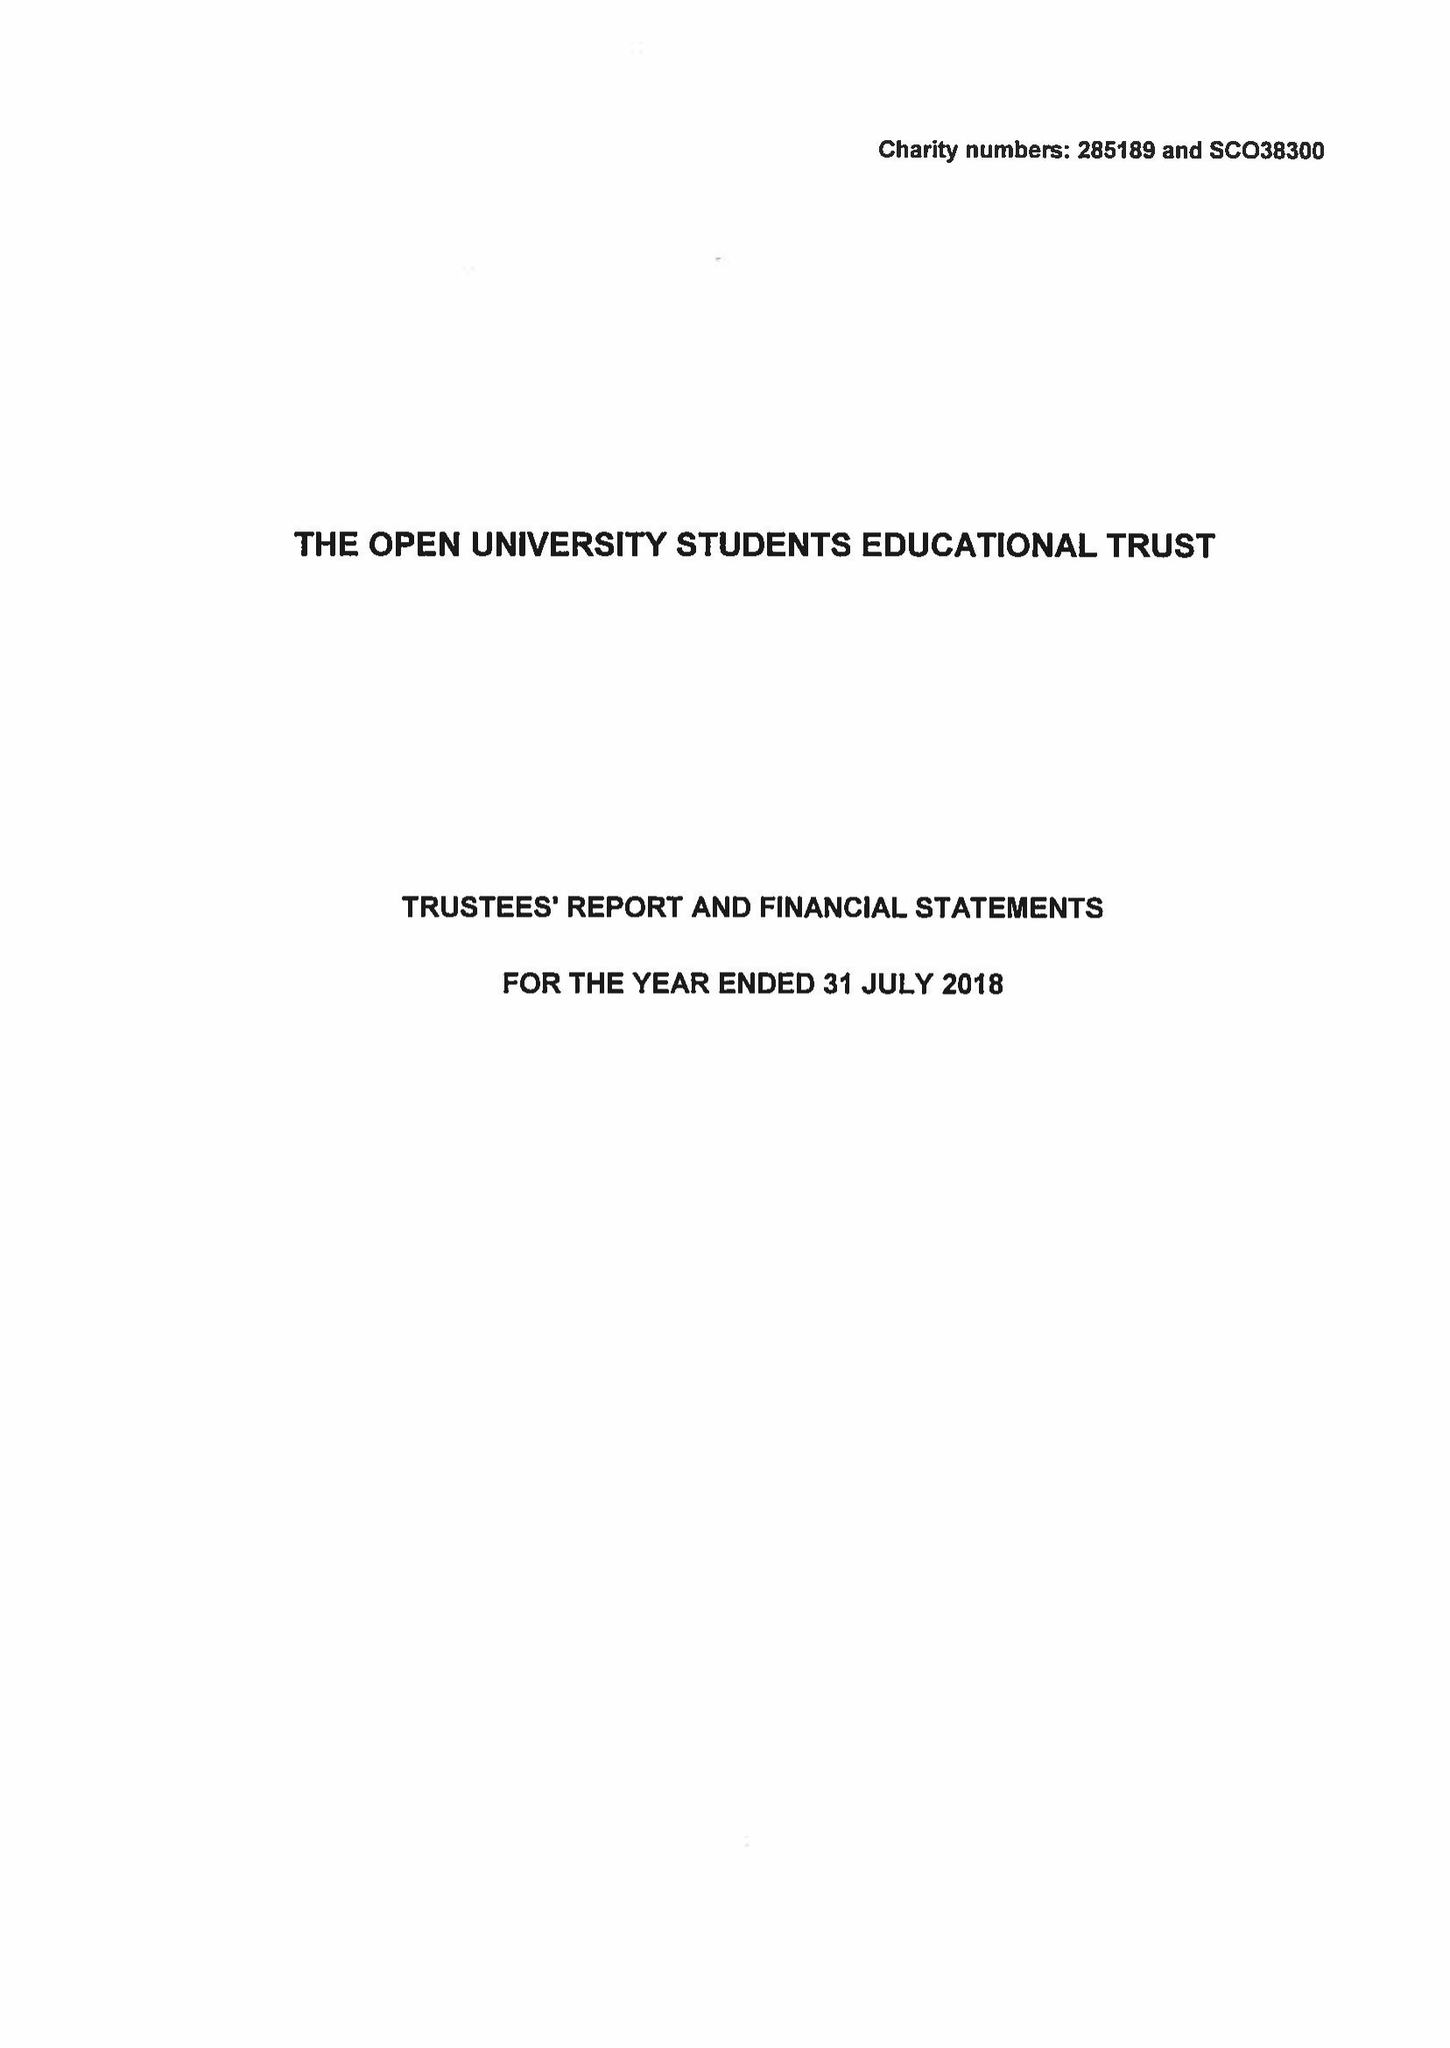What is the value for the income_annually_in_british_pounds?
Answer the question using a single word or phrase. 82561.00 